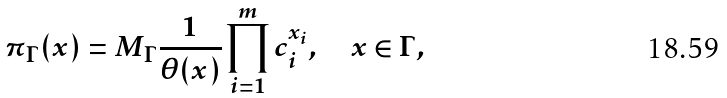Convert formula to latex. <formula><loc_0><loc_0><loc_500><loc_500>\pi _ { \Gamma } ( x ) = M _ { \Gamma } \frac { 1 } { \theta ( x ) } \prod _ { i = 1 } ^ { m } c _ { i } ^ { x _ { i } } , \quad x \in \Gamma ,</formula> 